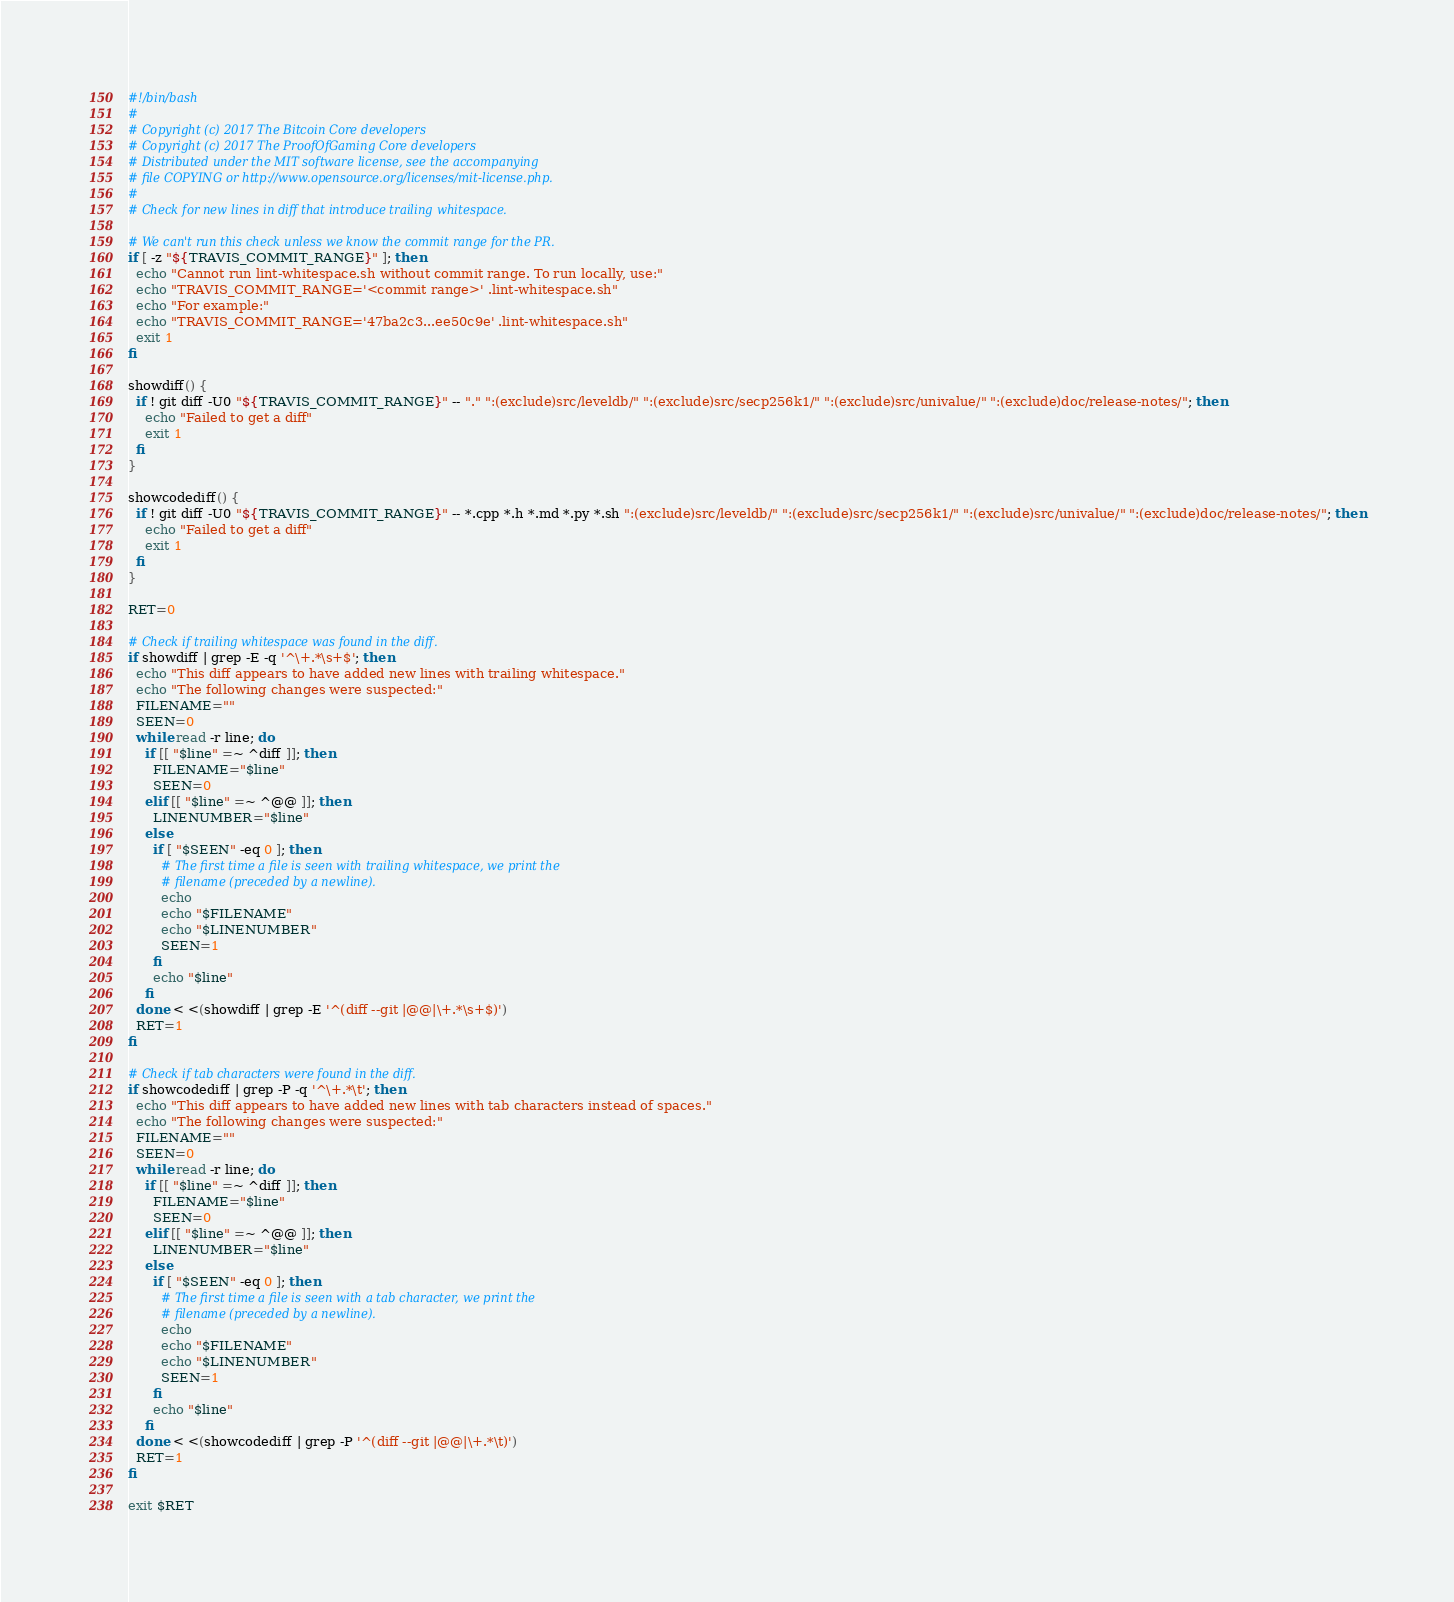Convert code to text. <code><loc_0><loc_0><loc_500><loc_500><_Bash_>#!/bin/bash
#
# Copyright (c) 2017 The Bitcoin Core developers
# Copyright (c) 2017 The ProofOfGaming Core developers
# Distributed under the MIT software license, see the accompanying
# file COPYING or http://www.opensource.org/licenses/mit-license.php.
#
# Check for new lines in diff that introduce trailing whitespace.

# We can't run this check unless we know the commit range for the PR.
if [ -z "${TRAVIS_COMMIT_RANGE}" ]; then
  echo "Cannot run lint-whitespace.sh without commit range. To run locally, use:"
  echo "TRAVIS_COMMIT_RANGE='<commit range>' .lint-whitespace.sh"
  echo "For example:"
  echo "TRAVIS_COMMIT_RANGE='47ba2c3...ee50c9e' .lint-whitespace.sh"
  exit 1
fi

showdiff() {
  if ! git diff -U0 "${TRAVIS_COMMIT_RANGE}" -- "." ":(exclude)src/leveldb/" ":(exclude)src/secp256k1/" ":(exclude)src/univalue/" ":(exclude)doc/release-notes/"; then
    echo "Failed to get a diff"
    exit 1
  fi
}

showcodediff() {
  if ! git diff -U0 "${TRAVIS_COMMIT_RANGE}" -- *.cpp *.h *.md *.py *.sh ":(exclude)src/leveldb/" ":(exclude)src/secp256k1/" ":(exclude)src/univalue/" ":(exclude)doc/release-notes/"; then
    echo "Failed to get a diff"
    exit 1
  fi
}

RET=0

# Check if trailing whitespace was found in the diff.
if showdiff | grep -E -q '^\+.*\s+$'; then
  echo "This diff appears to have added new lines with trailing whitespace."
  echo "The following changes were suspected:"
  FILENAME=""
  SEEN=0
  while read -r line; do
    if [[ "$line" =~ ^diff ]]; then
      FILENAME="$line"
      SEEN=0
    elif [[ "$line" =~ ^@@ ]]; then
      LINENUMBER="$line"
    else
      if [ "$SEEN" -eq 0 ]; then
        # The first time a file is seen with trailing whitespace, we print the
        # filename (preceded by a newline).
        echo
        echo "$FILENAME"
        echo "$LINENUMBER"
        SEEN=1
      fi
      echo "$line"
    fi
  done < <(showdiff | grep -E '^(diff --git |@@|\+.*\s+$)')
  RET=1
fi

# Check if tab characters were found in the diff.
if showcodediff | grep -P -q '^\+.*\t'; then
  echo "This diff appears to have added new lines with tab characters instead of spaces."
  echo "The following changes were suspected:"
  FILENAME=""
  SEEN=0
  while read -r line; do
    if [[ "$line" =~ ^diff ]]; then
      FILENAME="$line"
      SEEN=0
    elif [[ "$line" =~ ^@@ ]]; then
      LINENUMBER="$line"
    else
      if [ "$SEEN" -eq 0 ]; then
        # The first time a file is seen with a tab character, we print the
        # filename (preceded by a newline).
        echo
        echo "$FILENAME"
        echo "$LINENUMBER"
        SEEN=1
      fi
      echo "$line"
    fi
  done < <(showcodediff | grep -P '^(diff --git |@@|\+.*\t)')
  RET=1
fi

exit $RET
</code> 